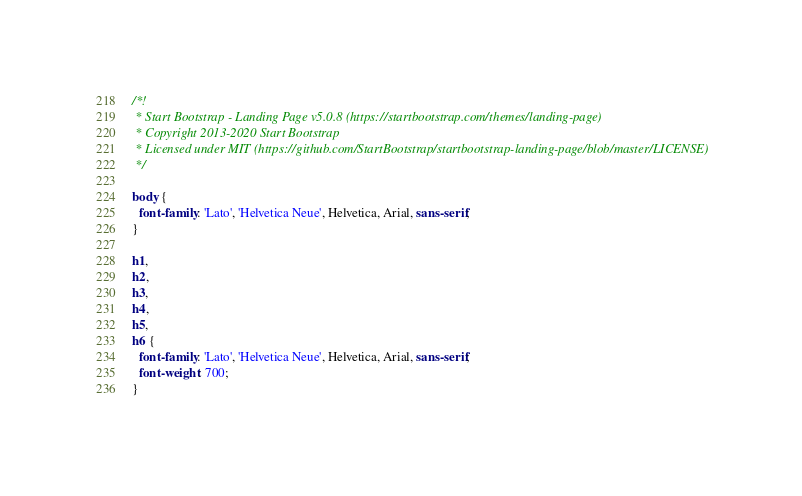Convert code to text. <code><loc_0><loc_0><loc_500><loc_500><_CSS_>/*!
 * Start Bootstrap - Landing Page v5.0.8 (https://startbootstrap.com/themes/landing-page)
 * Copyright 2013-2020 Start Bootstrap
 * Licensed under MIT (https://github.com/StartBootstrap/startbootstrap-landing-page/blob/master/LICENSE)
 */

body {
  font-family: 'Lato', 'Helvetica Neue', Helvetica, Arial, sans-serif;
}

h1,
h2,
h3,
h4,
h5,
h6 {
  font-family: 'Lato', 'Helvetica Neue', Helvetica, Arial, sans-serif;
  font-weight: 700;
}
</code> 